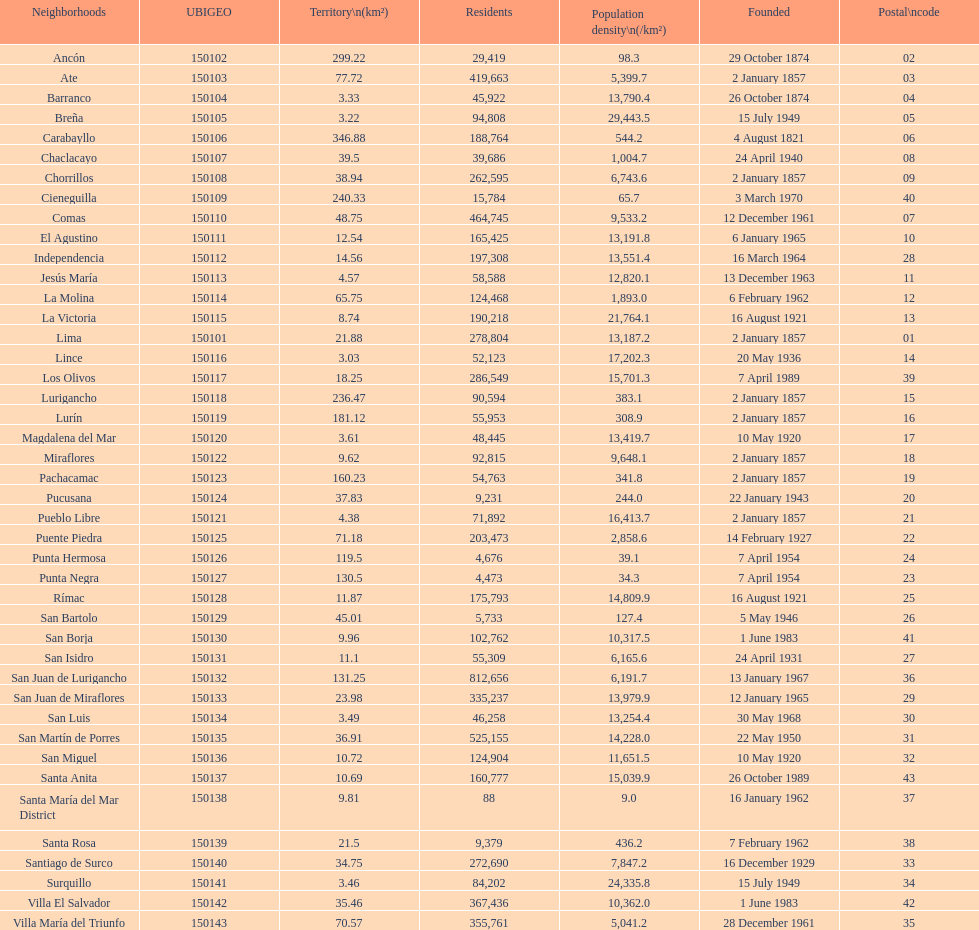How many districts have more than 100,000 people in this city? 21. 